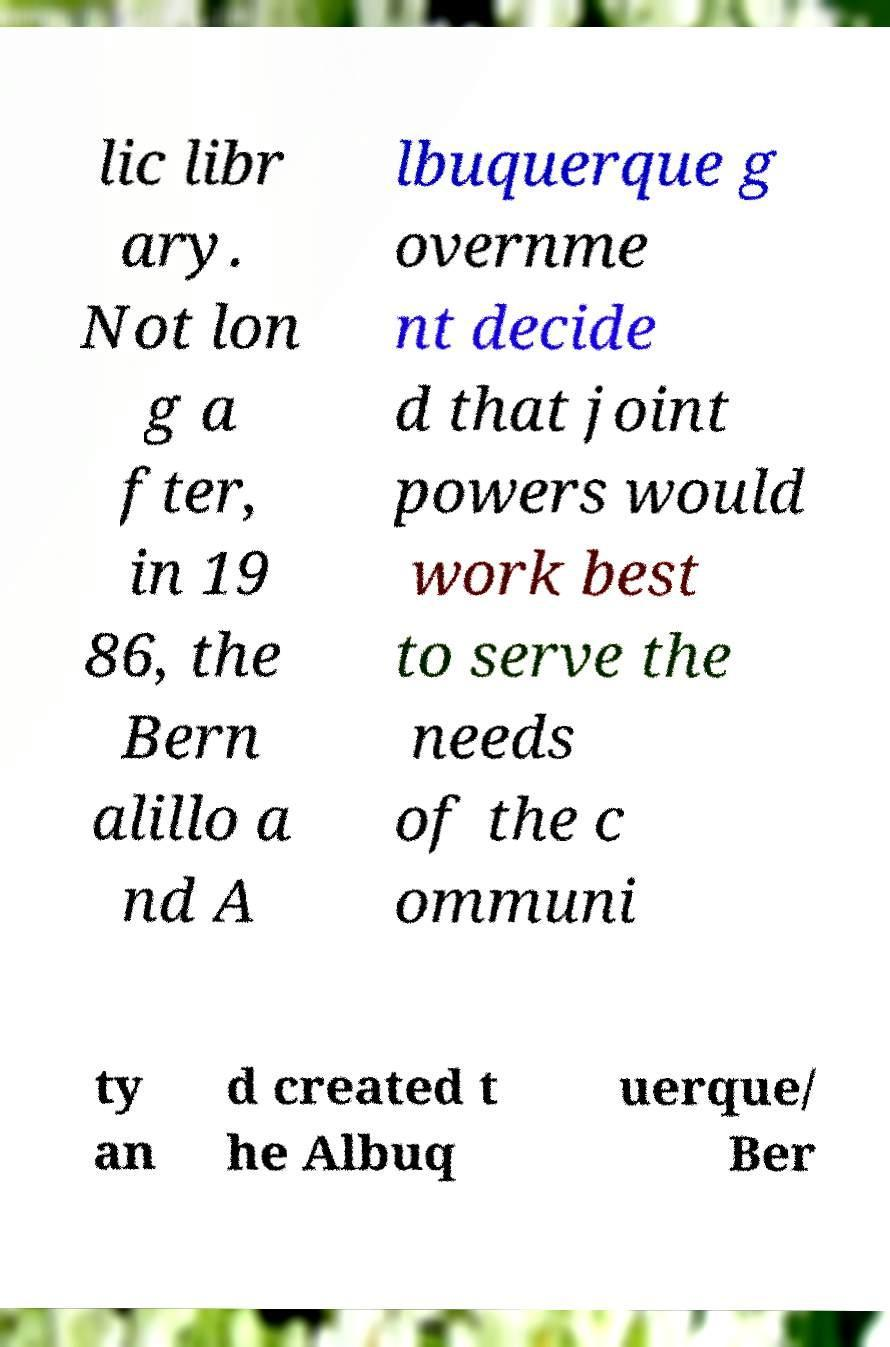For documentation purposes, I need the text within this image transcribed. Could you provide that? lic libr ary. Not lon g a fter, in 19 86, the Bern alillo a nd A lbuquerque g overnme nt decide d that joint powers would work best to serve the needs of the c ommuni ty an d created t he Albuq uerque/ Ber 